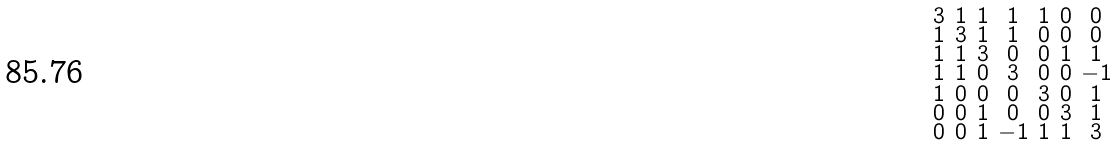Convert formula to latex. <formula><loc_0><loc_0><loc_500><loc_500>\begin{smallmatrix} 3 & 1 & 1 & 1 & 1 & 0 & 0 \\ 1 & 3 & 1 & 1 & 0 & 0 & 0 \\ 1 & 1 & 3 & 0 & 0 & 1 & 1 \\ 1 & 1 & 0 & 3 & 0 & 0 & - 1 \\ 1 & 0 & 0 & 0 & 3 & 0 & 1 \\ 0 & 0 & 1 & 0 & 0 & 3 & 1 \\ 0 & 0 & 1 & - 1 & 1 & 1 & 3 \end{smallmatrix}</formula> 